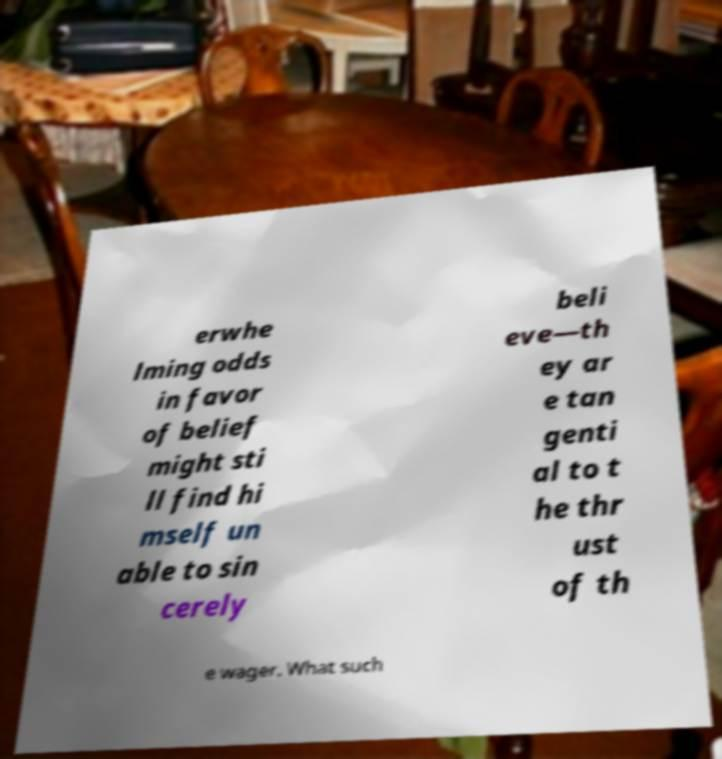Please identify and transcribe the text found in this image. erwhe lming odds in favor of belief might sti ll find hi mself un able to sin cerely beli eve—th ey ar e tan genti al to t he thr ust of th e wager. What such 